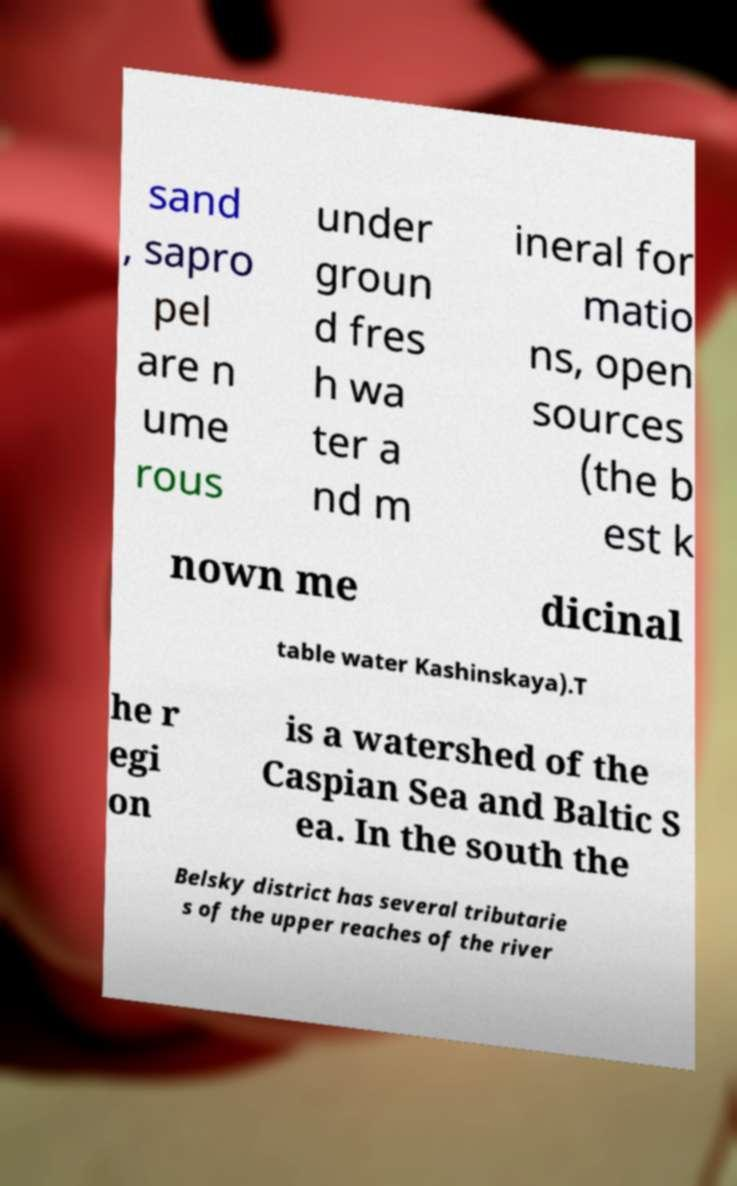Could you extract and type out the text from this image? sand , sapro pel are n ume rous under groun d fres h wa ter a nd m ineral for matio ns, open sources (the b est k nown me dicinal table water Kashinskaya).T he r egi on is a watershed of the Caspian Sea and Baltic S ea. In the south the Belsky district has several tributarie s of the upper reaches of the river 